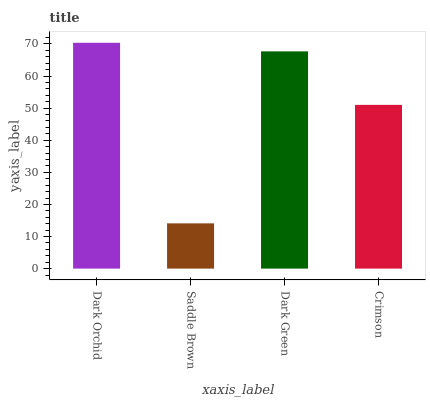Is Saddle Brown the minimum?
Answer yes or no. Yes. Is Dark Orchid the maximum?
Answer yes or no. Yes. Is Dark Green the minimum?
Answer yes or no. No. Is Dark Green the maximum?
Answer yes or no. No. Is Dark Green greater than Saddle Brown?
Answer yes or no. Yes. Is Saddle Brown less than Dark Green?
Answer yes or no. Yes. Is Saddle Brown greater than Dark Green?
Answer yes or no. No. Is Dark Green less than Saddle Brown?
Answer yes or no. No. Is Dark Green the high median?
Answer yes or no. Yes. Is Crimson the low median?
Answer yes or no. Yes. Is Saddle Brown the high median?
Answer yes or no. No. Is Dark Green the low median?
Answer yes or no. No. 